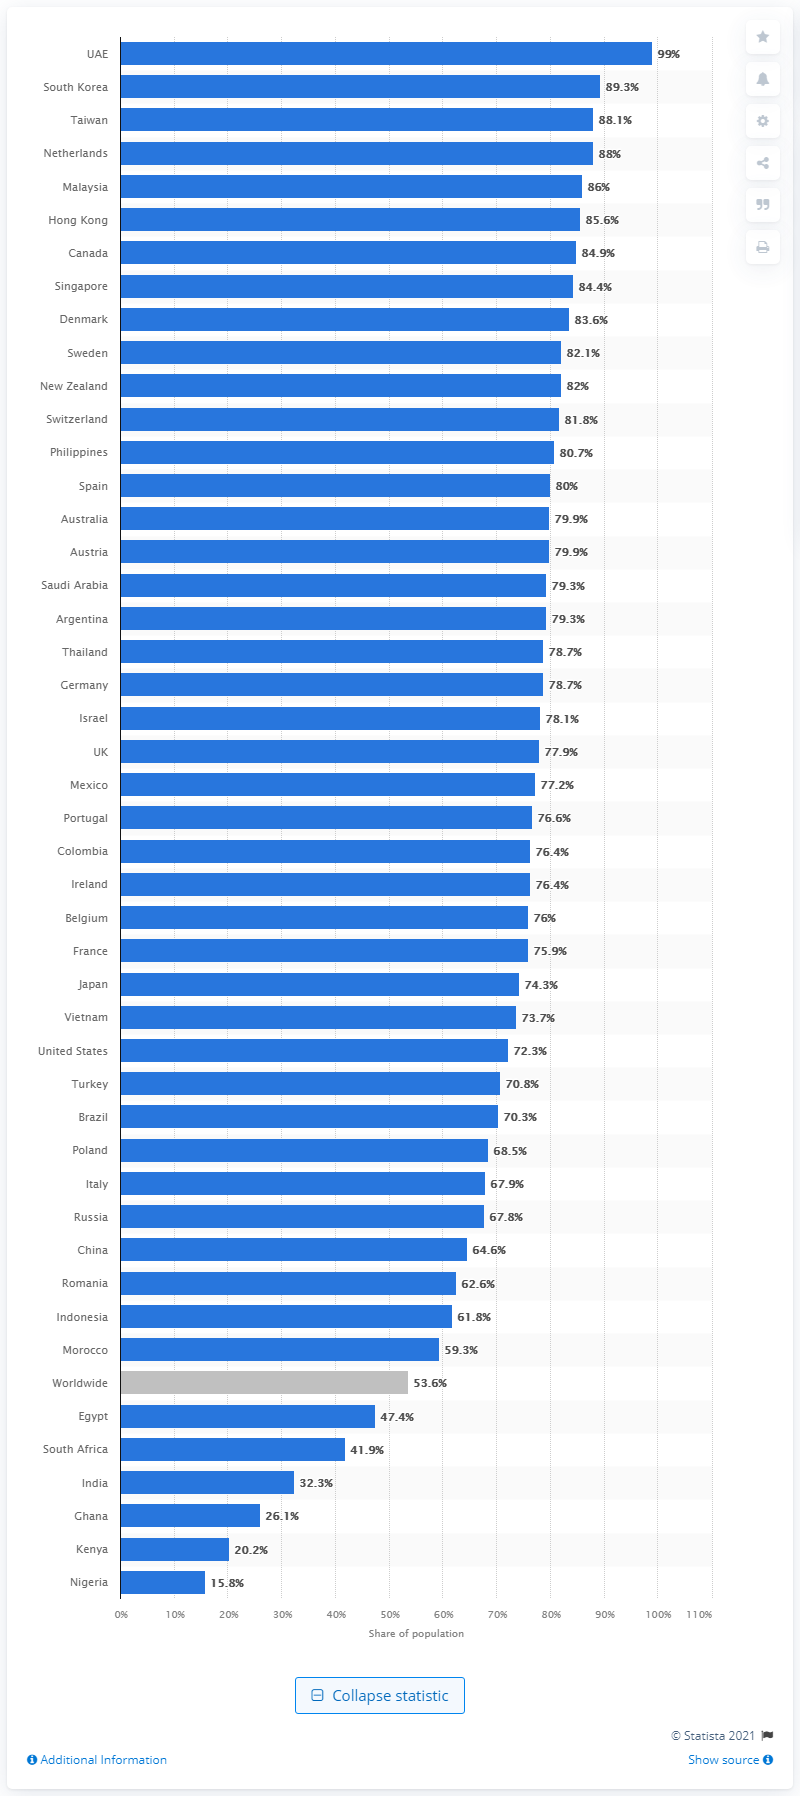Draw attention to some important aspects in this diagram. South Korea ranked second in social media usage penetration, with over 89 percent of its population actively using social media platforms. 